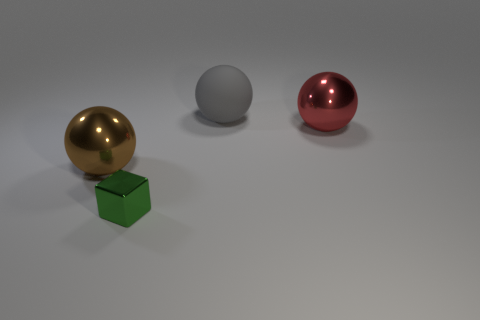Add 2 big purple metallic cylinders. How many objects exist? 6 Subtract all balls. How many objects are left? 1 Subtract 0 yellow cylinders. How many objects are left? 4 Subtract all tiny things. Subtract all large metal objects. How many objects are left? 1 Add 3 big brown things. How many big brown things are left? 4 Add 1 red shiny balls. How many red shiny balls exist? 2 